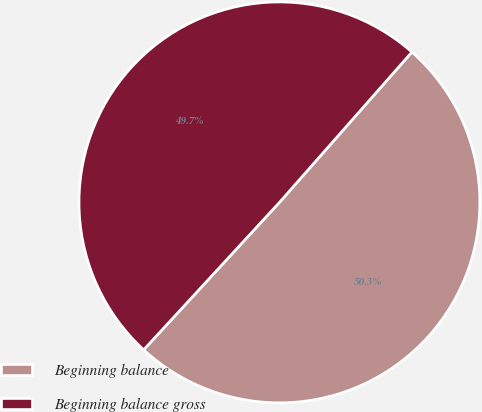<chart> <loc_0><loc_0><loc_500><loc_500><pie_chart><fcel>Beginning balance<fcel>Beginning balance gross<nl><fcel>50.35%<fcel>49.65%<nl></chart> 